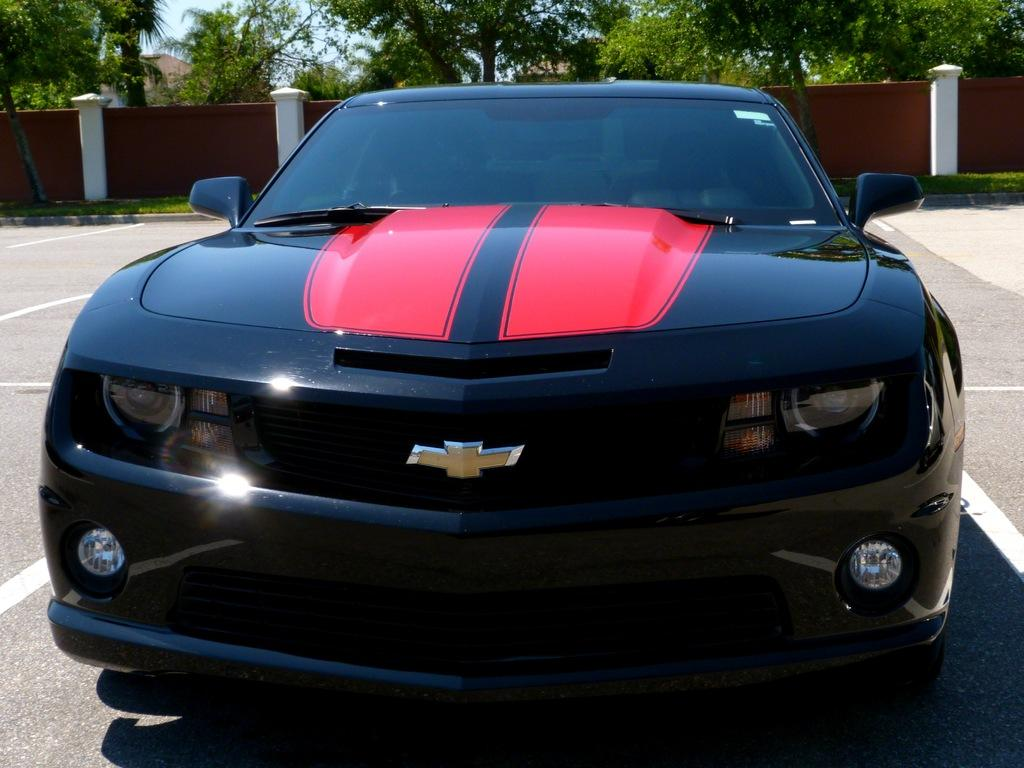What is the main subject of the image? The main subject of the image is a car on the road. What can be seen behind the car? There is a wall visible behind the car, as well as some objects. What type of vegetation is visible in the image? There are trees visible in the image. What is visible in the background of the image? The sky is visible in the background of the image. What type of fruit is being divided by the laborer in the image? There is no laborer or fruit present in the image; it features a car on the road with a wall, objects, trees, and the sky visible in the background. 